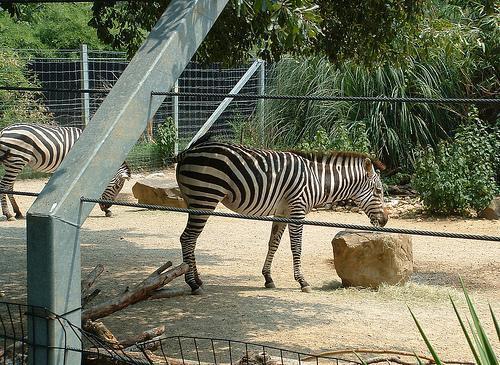How many animals are present?
Give a very brief answer. 2. 